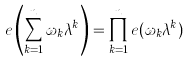<formula> <loc_0><loc_0><loc_500><loc_500>e \left ( \sum _ { k = 1 } ^ { n } \omega _ { k } \lambda ^ { k } \right ) = \prod _ { k = 1 } ^ { n } e ( \omega _ { k } \lambda ^ { k } )</formula> 